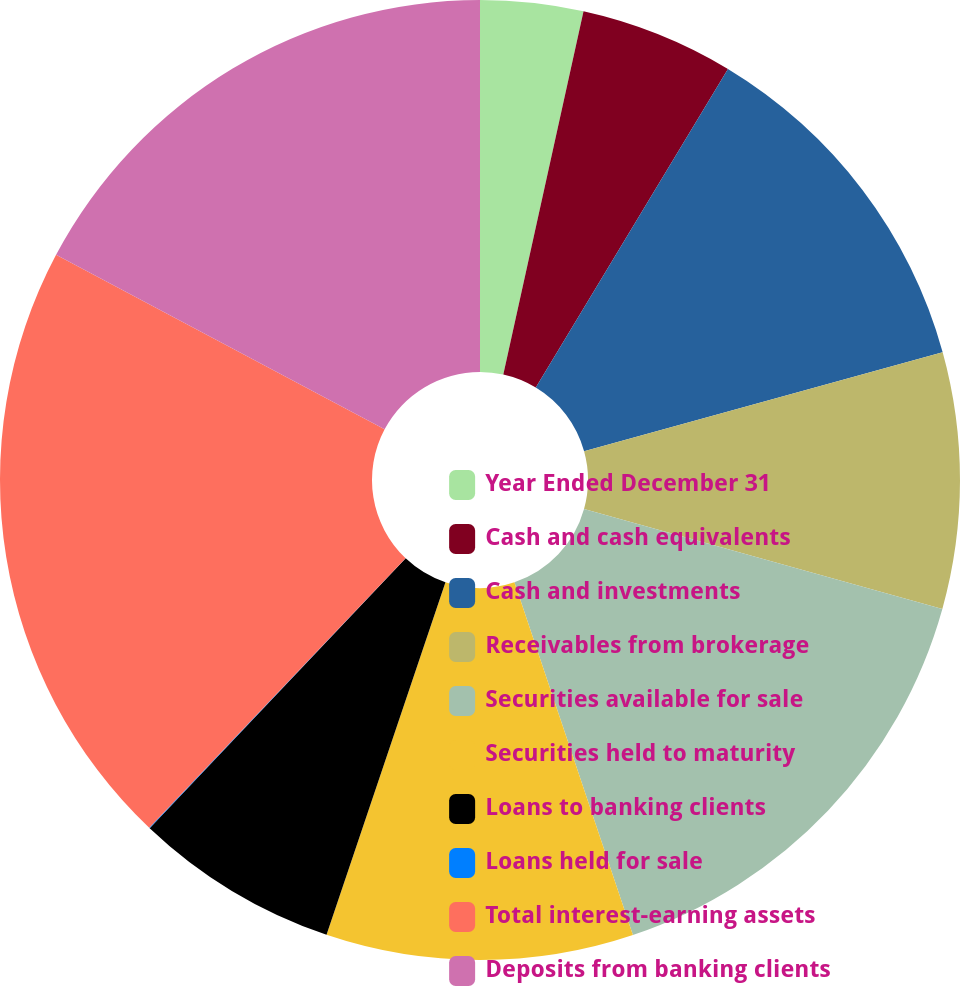Convert chart to OTSL. <chart><loc_0><loc_0><loc_500><loc_500><pie_chart><fcel>Year Ended December 31<fcel>Cash and cash equivalents<fcel>Cash and investments<fcel>Receivables from brokerage<fcel>Securities available for sale<fcel>Securities held to maturity<fcel>Loans to banking clients<fcel>Loans held for sale<fcel>Total interest-earning assets<fcel>Deposits from banking clients<nl><fcel>3.46%<fcel>5.18%<fcel>12.07%<fcel>8.62%<fcel>15.51%<fcel>10.34%<fcel>6.9%<fcel>0.02%<fcel>20.67%<fcel>17.23%<nl></chart> 